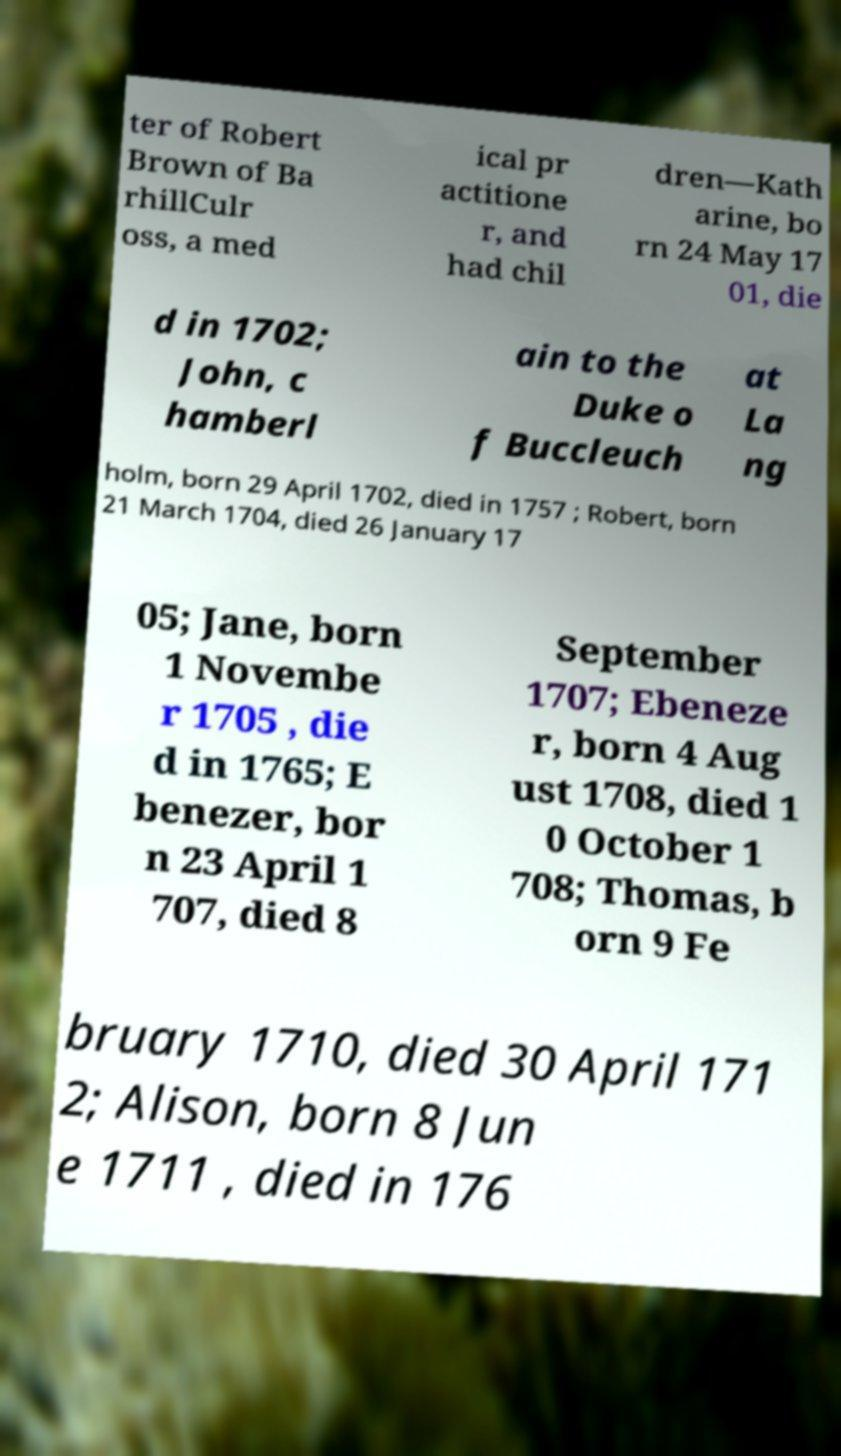Can you read and provide the text displayed in the image?This photo seems to have some interesting text. Can you extract and type it out for me? ter of Robert Brown of Ba rhillCulr oss, a med ical pr actitione r, and had chil dren—Kath arine, bo rn 24 May 17 01, die d in 1702; John, c hamberl ain to the Duke o f Buccleuch at La ng holm, born 29 April 1702, died in 1757 ; Robert, born 21 March 1704, died 26 January 17 05; Jane, born 1 Novembe r 1705 , die d in 1765; E benezer, bor n 23 April 1 707, died 8 September 1707; Ebeneze r, born 4 Aug ust 1708, died 1 0 October 1 708; Thomas, b orn 9 Fe bruary 1710, died 30 April 171 2; Alison, born 8 Jun e 1711 , died in 176 